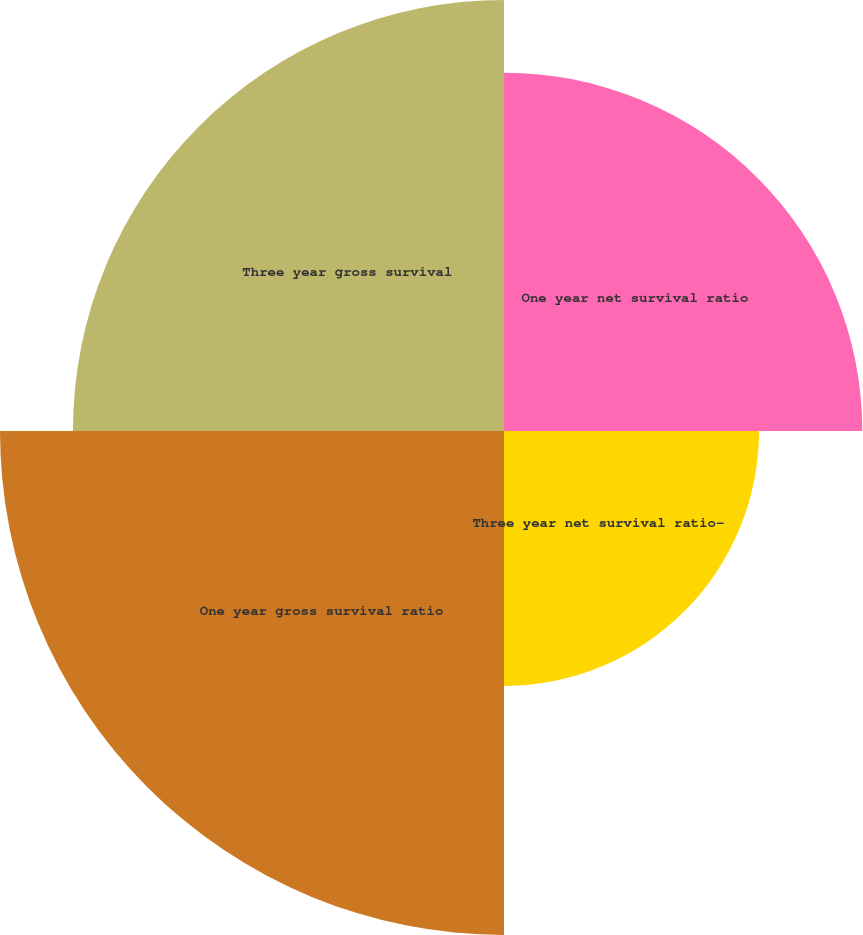Convert chart to OTSL. <chart><loc_0><loc_0><loc_500><loc_500><pie_chart><fcel>One year net survival ratio<fcel>Three year net survival ratio-<fcel>One year gross survival ratio<fcel>Three year gross survival<nl><fcel>23.14%<fcel>16.47%<fcel>32.55%<fcel>27.84%<nl></chart> 